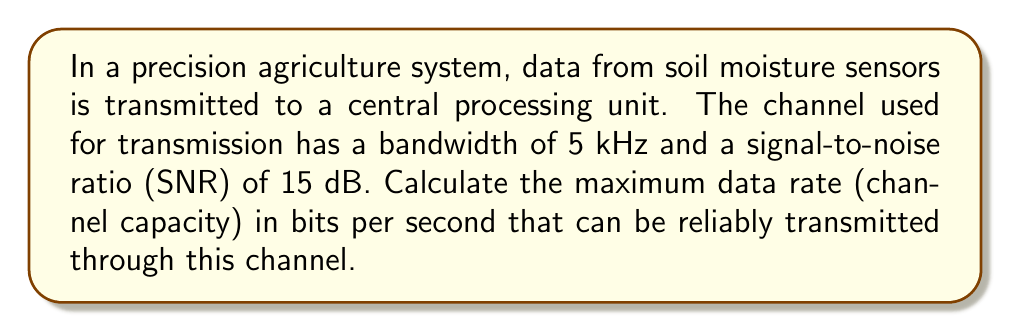Give your solution to this math problem. To solve this problem, we'll use the Shannon-Hartley theorem, which provides a formula for calculating the channel capacity. The steps are as follows:

1. Recall the Shannon-Hartley theorem:
   $$C = B \log_2(1 + SNR)$$
   where:
   $C$ is the channel capacity in bits per second (bps)
   $B$ is the bandwidth in Hz
   $SNR$ is the signal-to-noise ratio (linear, not dB)

2. We're given:
   $B = 5 \text{ kHz} = 5000 \text{ Hz}$
   $SNR = 15 \text{ dB}$

3. Convert SNR from dB to linear scale:
   $$SNR_{linear} = 10^{SNR_{dB}/10} = 10^{15/10} = 10^{1.5} \approx 31.6228$$

4. Apply the Shannon-Hartley theorem:
   $$\begin{align}
   C &= 5000 \log_2(1 + 31.6228) \\
   &= 5000 \log_2(32.6228) \\
   &\approx 5000 \times 5.0279 \\
   &\approx 25139.5 \text{ bps}
   \end{align}$$

5. Round to the nearest whole number:
   $$C \approx 25140 \text{ bps}$$
Answer: The maximum data rate (channel capacity) that can be reliably transmitted through this channel is approximately 25140 bits per second. 